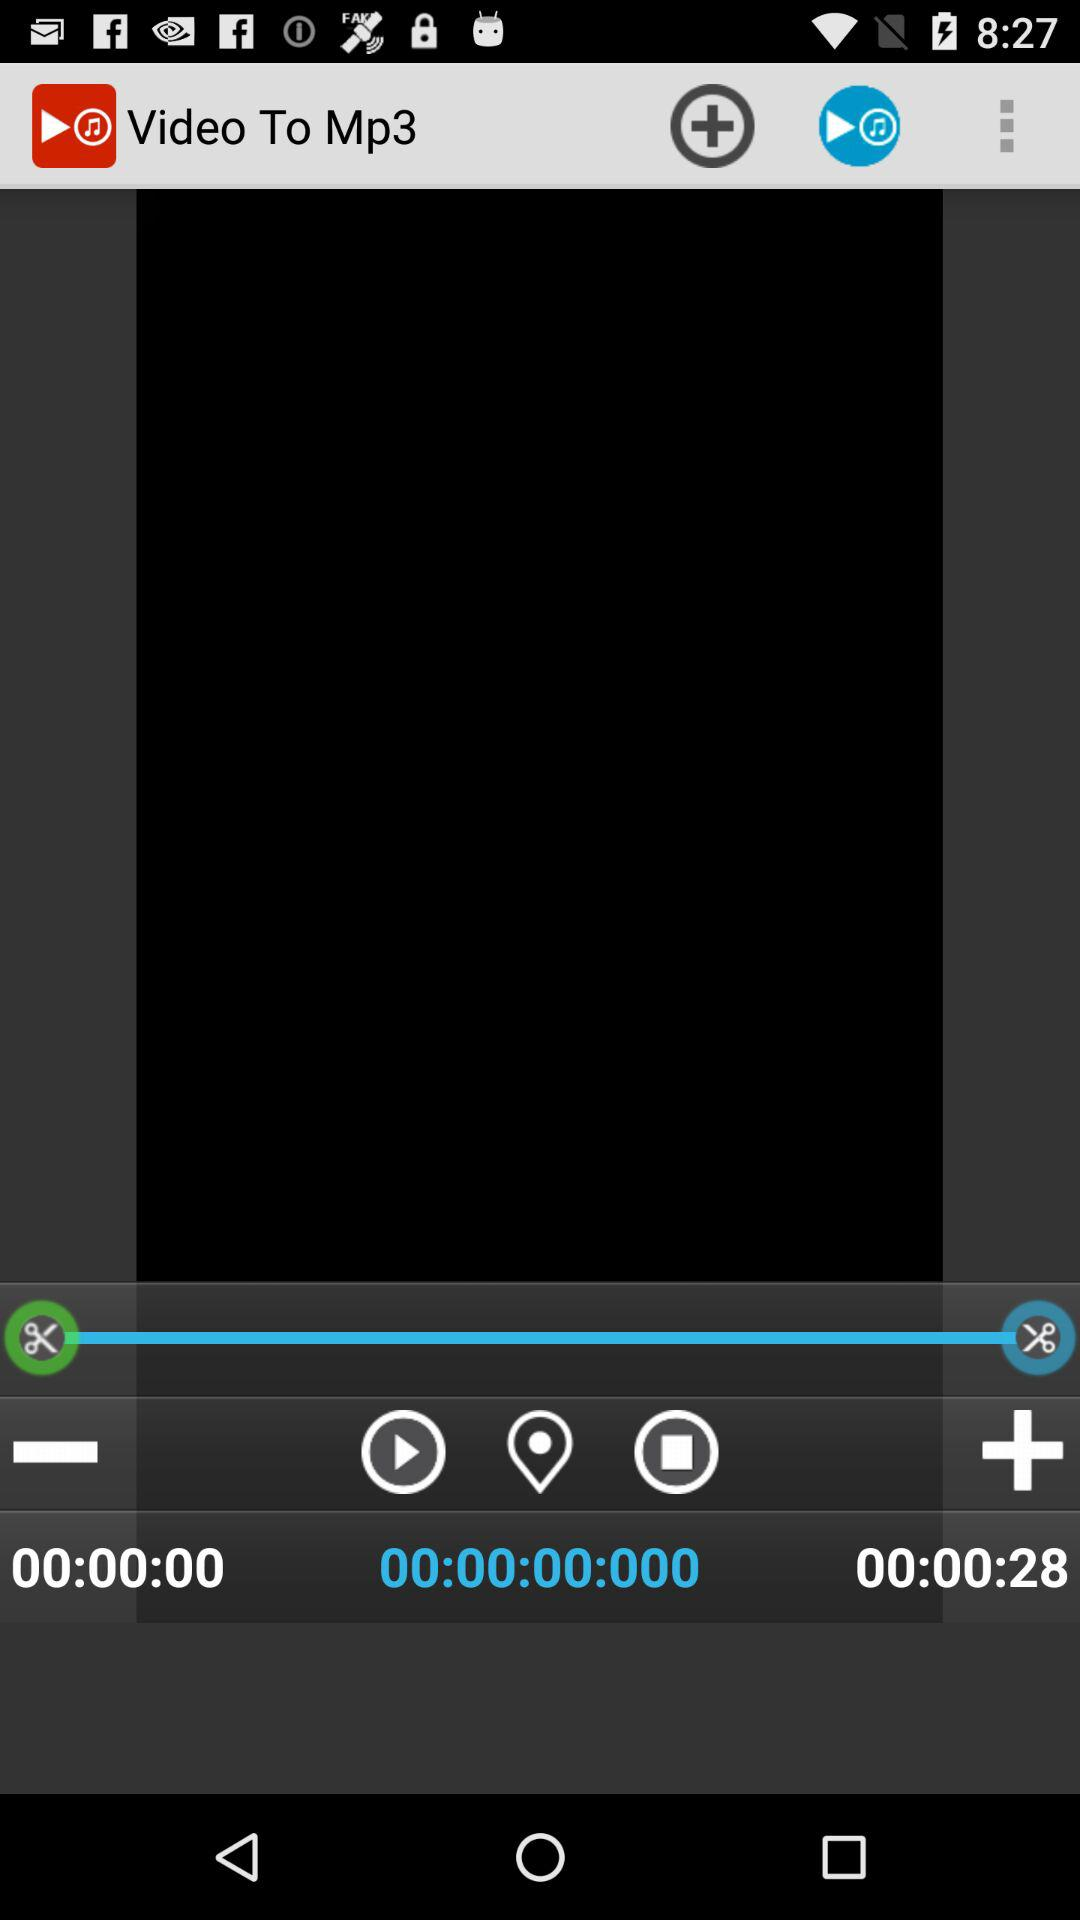What is the name of the application? The name of the application is "Video To Mp3". 